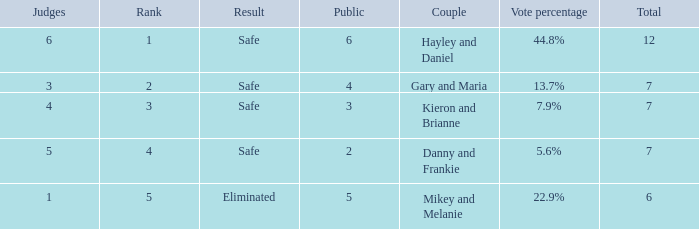What was the total number when the vote percentage was 44.8%? 1.0. 